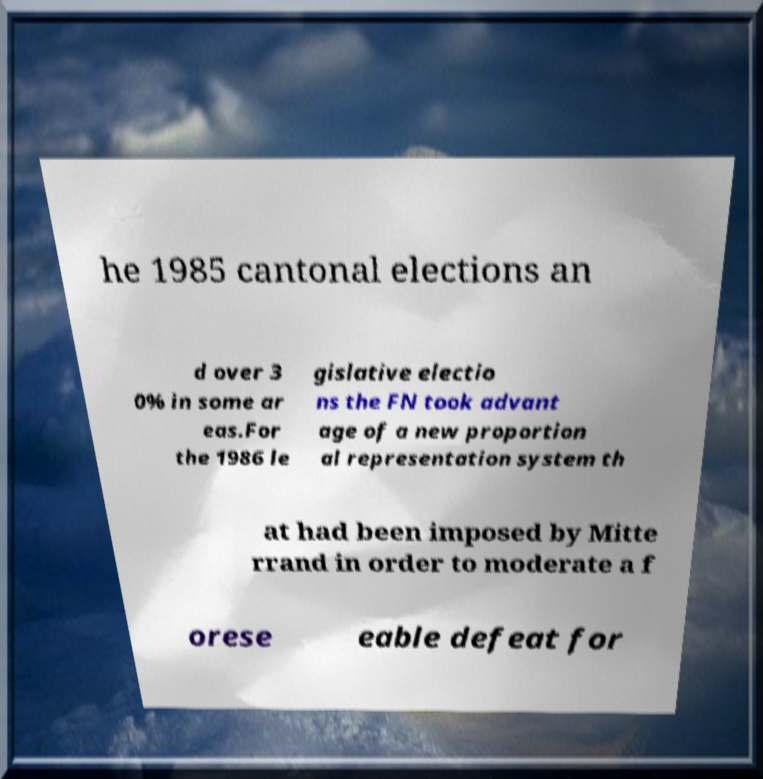What messages or text are displayed in this image? I need them in a readable, typed format. he 1985 cantonal elections an d over 3 0% in some ar eas.For the 1986 le gislative electio ns the FN took advant age of a new proportion al representation system th at had been imposed by Mitte rrand in order to moderate a f orese eable defeat for 